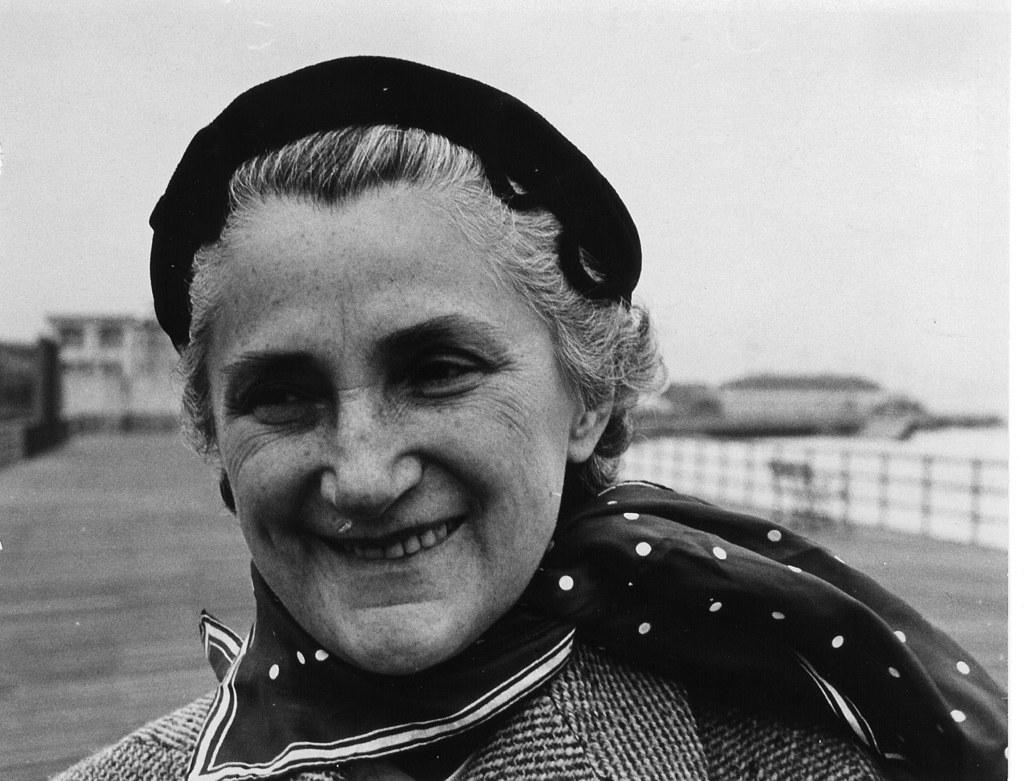What is the color scheme of the image? The image is black and white. Who is the main subject in the foreground of the image? There is a woman in the foreground of the image. What can be observed about the background of the woman? The background of the woman is blurred. What type of teeth can be seen in the image? There are no teeth visible in the image, as it features a woman in the foreground with a blurred background. 